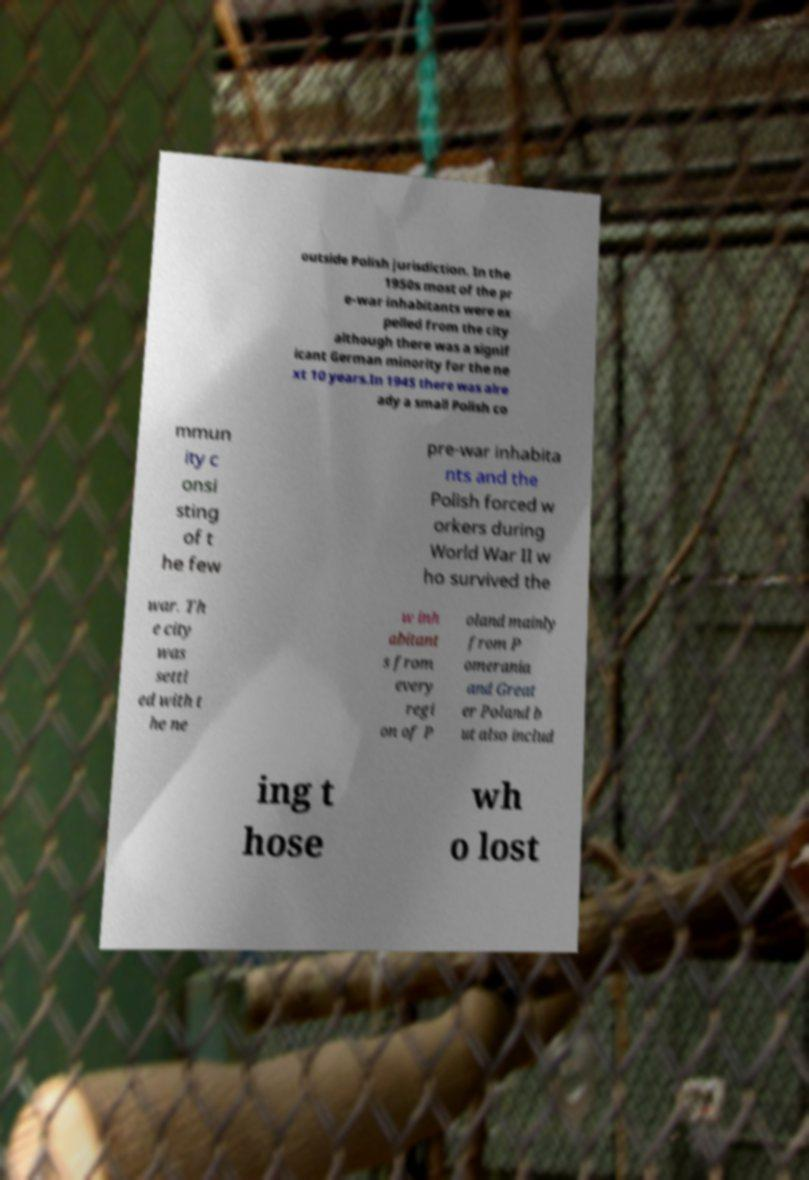For documentation purposes, I need the text within this image transcribed. Could you provide that? outside Polish jurisdiction. In the 1950s most of the pr e-war inhabitants were ex pelled from the city although there was a signif icant German minority for the ne xt 10 years.In 1945 there was alre ady a small Polish co mmun ity c onsi sting of t he few pre-war inhabita nts and the Polish forced w orkers during World War II w ho survived the war. Th e city was settl ed with t he ne w inh abitant s from every regi on of P oland mainly from P omerania and Great er Poland b ut also includ ing t hose wh o lost 